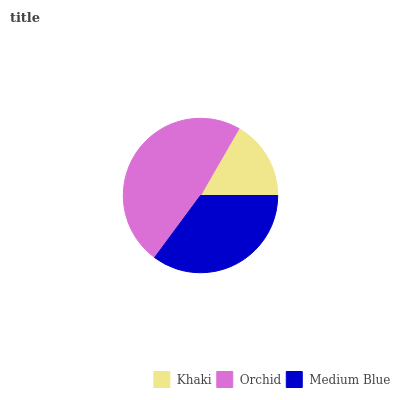Is Khaki the minimum?
Answer yes or no. Yes. Is Orchid the maximum?
Answer yes or no. Yes. Is Medium Blue the minimum?
Answer yes or no. No. Is Medium Blue the maximum?
Answer yes or no. No. Is Orchid greater than Medium Blue?
Answer yes or no. Yes. Is Medium Blue less than Orchid?
Answer yes or no. Yes. Is Medium Blue greater than Orchid?
Answer yes or no. No. Is Orchid less than Medium Blue?
Answer yes or no. No. Is Medium Blue the high median?
Answer yes or no. Yes. Is Medium Blue the low median?
Answer yes or no. Yes. Is Orchid the high median?
Answer yes or no. No. Is Orchid the low median?
Answer yes or no. No. 